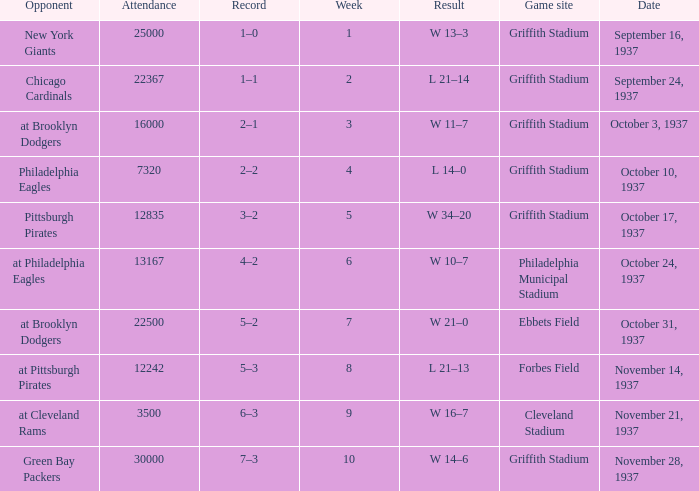What are week 4 results?  L 14–0. 